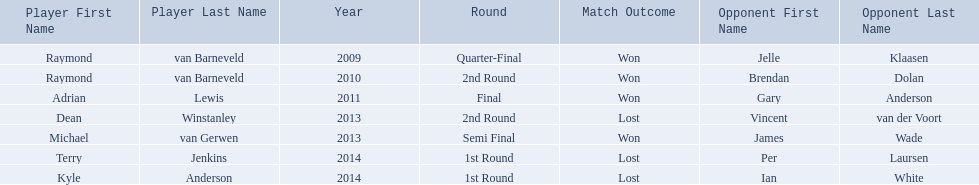What was the names of all the players? Raymond van Barneveld, Raymond van Barneveld, Adrian Lewis, Dean Winstanley, Michael van Gerwen, Terry Jenkins, Kyle Anderson. What years were the championship offered? 2009, 2010, 2011, 2013, 2013, 2014, 2014. Of these, who played in 2011? Adrian Lewis. 